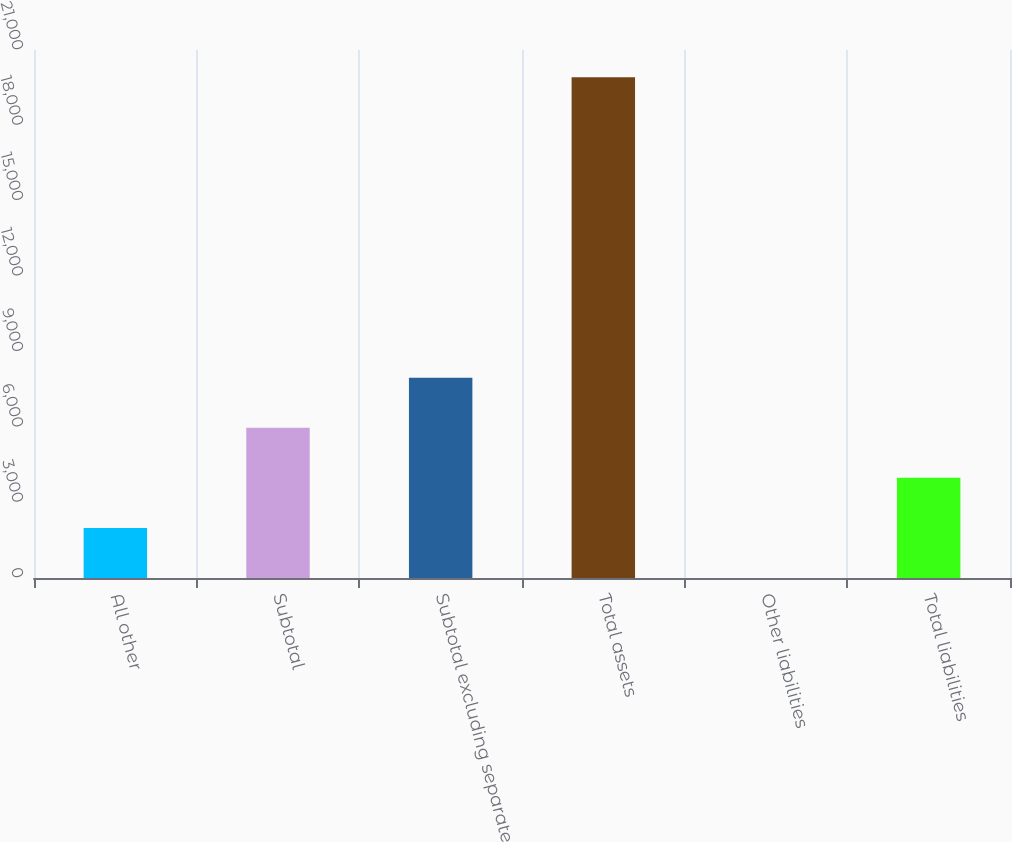Convert chart to OTSL. <chart><loc_0><loc_0><loc_500><loc_500><bar_chart><fcel>All other<fcel>Subtotal<fcel>Subtotal excluding separate<fcel>Total assets<fcel>Other liabilities<fcel>Total liabilities<nl><fcel>1993.2<fcel>5975.6<fcel>7966.8<fcel>19914<fcel>2<fcel>3984.4<nl></chart> 